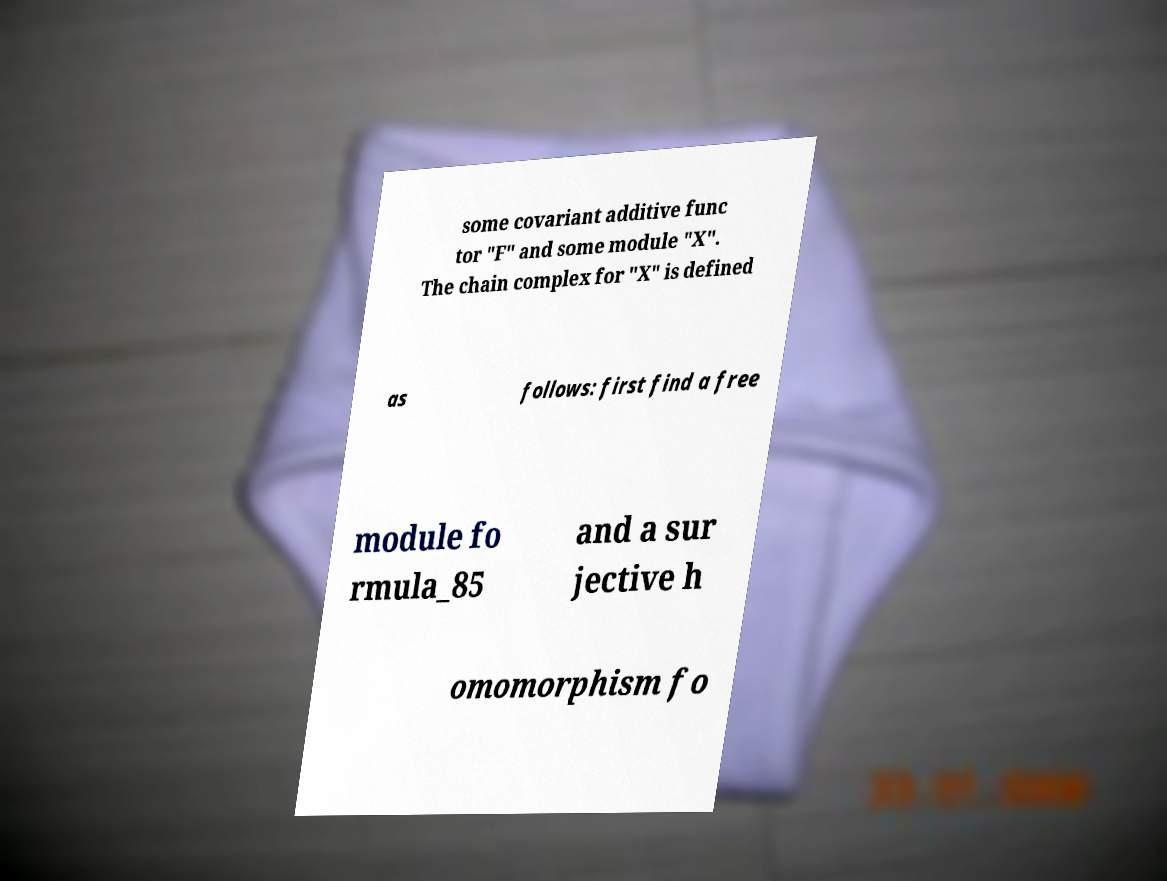There's text embedded in this image that I need extracted. Can you transcribe it verbatim? some covariant additive func tor "F" and some module "X". The chain complex for "X" is defined as follows: first find a free module fo rmula_85 and a sur jective h omomorphism fo 